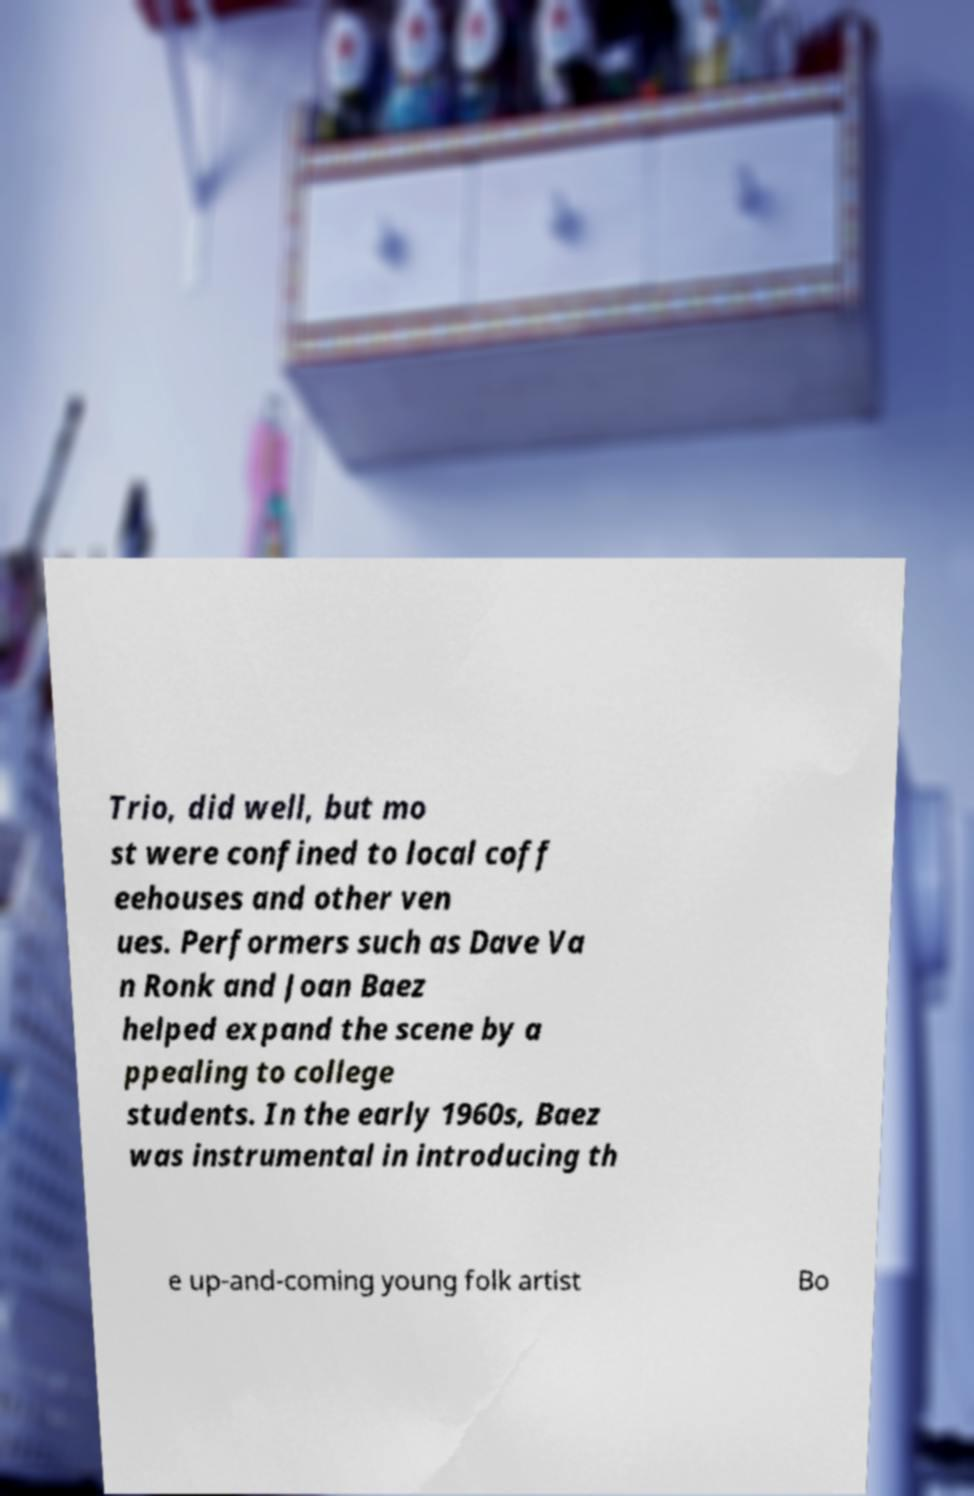Could you extract and type out the text from this image? Trio, did well, but mo st were confined to local coff eehouses and other ven ues. Performers such as Dave Va n Ronk and Joan Baez helped expand the scene by a ppealing to college students. In the early 1960s, Baez was instrumental in introducing th e up-and-coming young folk artist Bo 